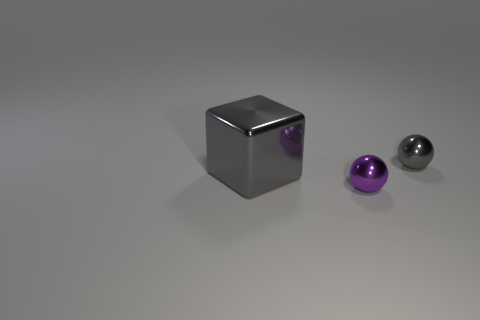Subtract all blue spheres. Subtract all purple cubes. How many spheres are left? 2 Add 2 small gray metallic balls. How many objects exist? 5 Subtract all spheres. How many objects are left? 1 Subtract all purple objects. Subtract all purple metallic balls. How many objects are left? 1 Add 1 small objects. How many small objects are left? 3 Add 2 tiny things. How many tiny things exist? 4 Subtract 0 red spheres. How many objects are left? 3 